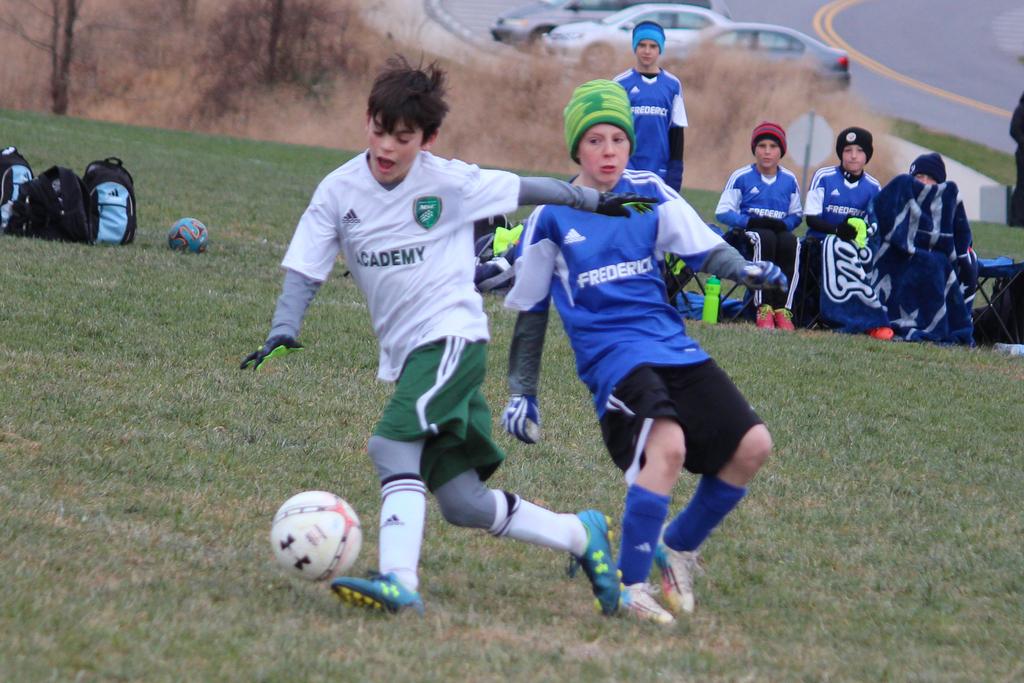What word is found on the blue jersey?
Your answer should be compact. Frederick. 